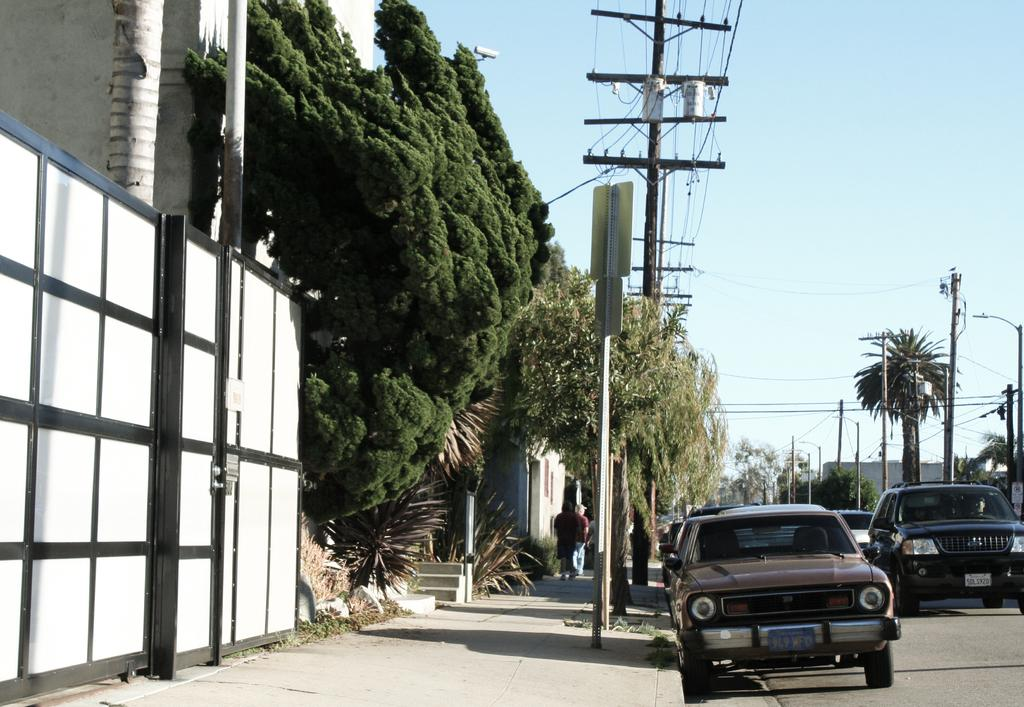What type of vehicles can be seen on the road in the image? There are cars on the road in the image. What are the two people on the footpath doing? The information provided does not specify what the two people are doing. What structures can be seen in the image? There are poles, buildings, and a gate visible in the image. What type of vegetation is present in the image? There are trees and grass in the image. What is visible in the background of the image? The sky is visible in the background of the image. What else can be seen in the image? There are wires, boards, and a footpath visible in the image. What type of acoustics can be heard from the gate in the image? There is no information about the acoustics in the image, and the gate is not described as making any sounds. On which side of the image is the gate located? The information provided does not specify the side of the image where the gate is located. 